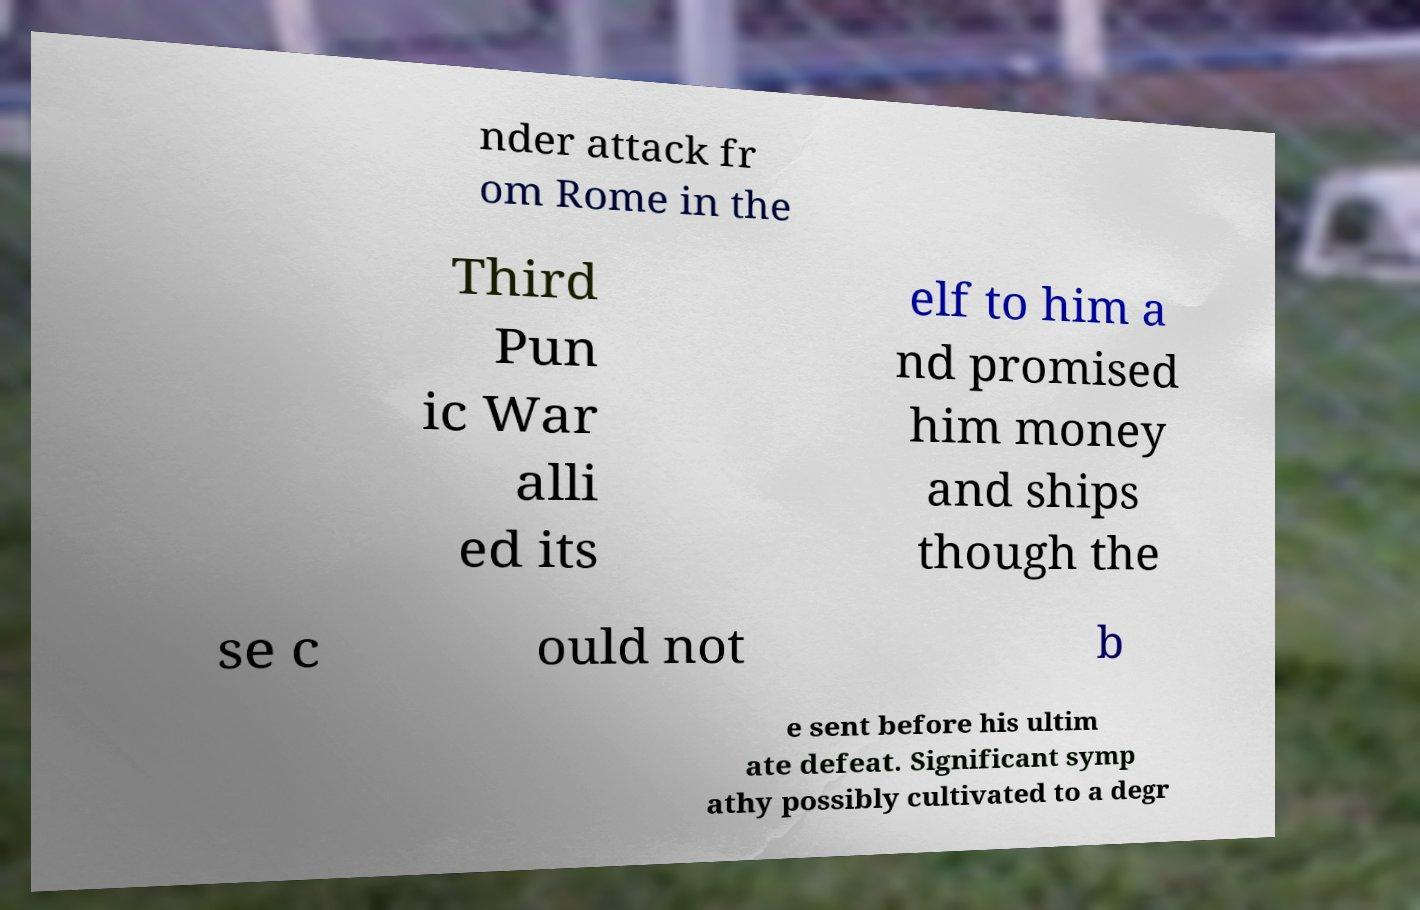Can you read and provide the text displayed in the image?This photo seems to have some interesting text. Can you extract and type it out for me? nder attack fr om Rome in the Third Pun ic War alli ed its elf to him a nd promised him money and ships though the se c ould not b e sent before his ultim ate defeat. Significant symp athy possibly cultivated to a degr 